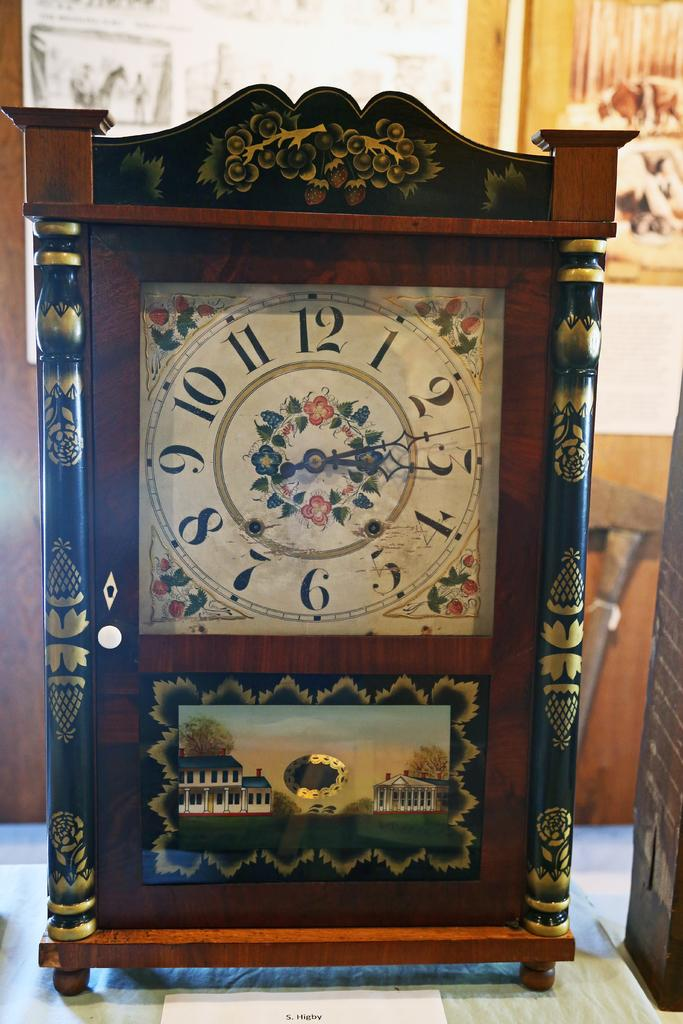<image>
Give a short and clear explanation of the subsequent image. The hands of a decorative clock are arranged at about 13 minutes after 12. 